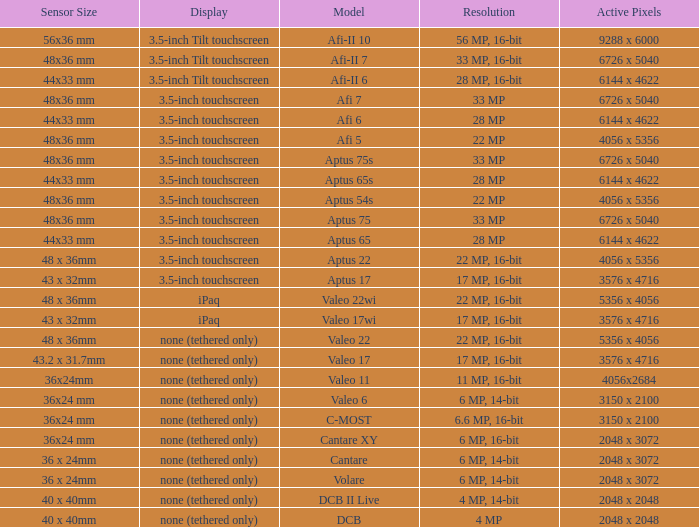What are the active pixels of the c-most model camera? 3150 x 2100. 